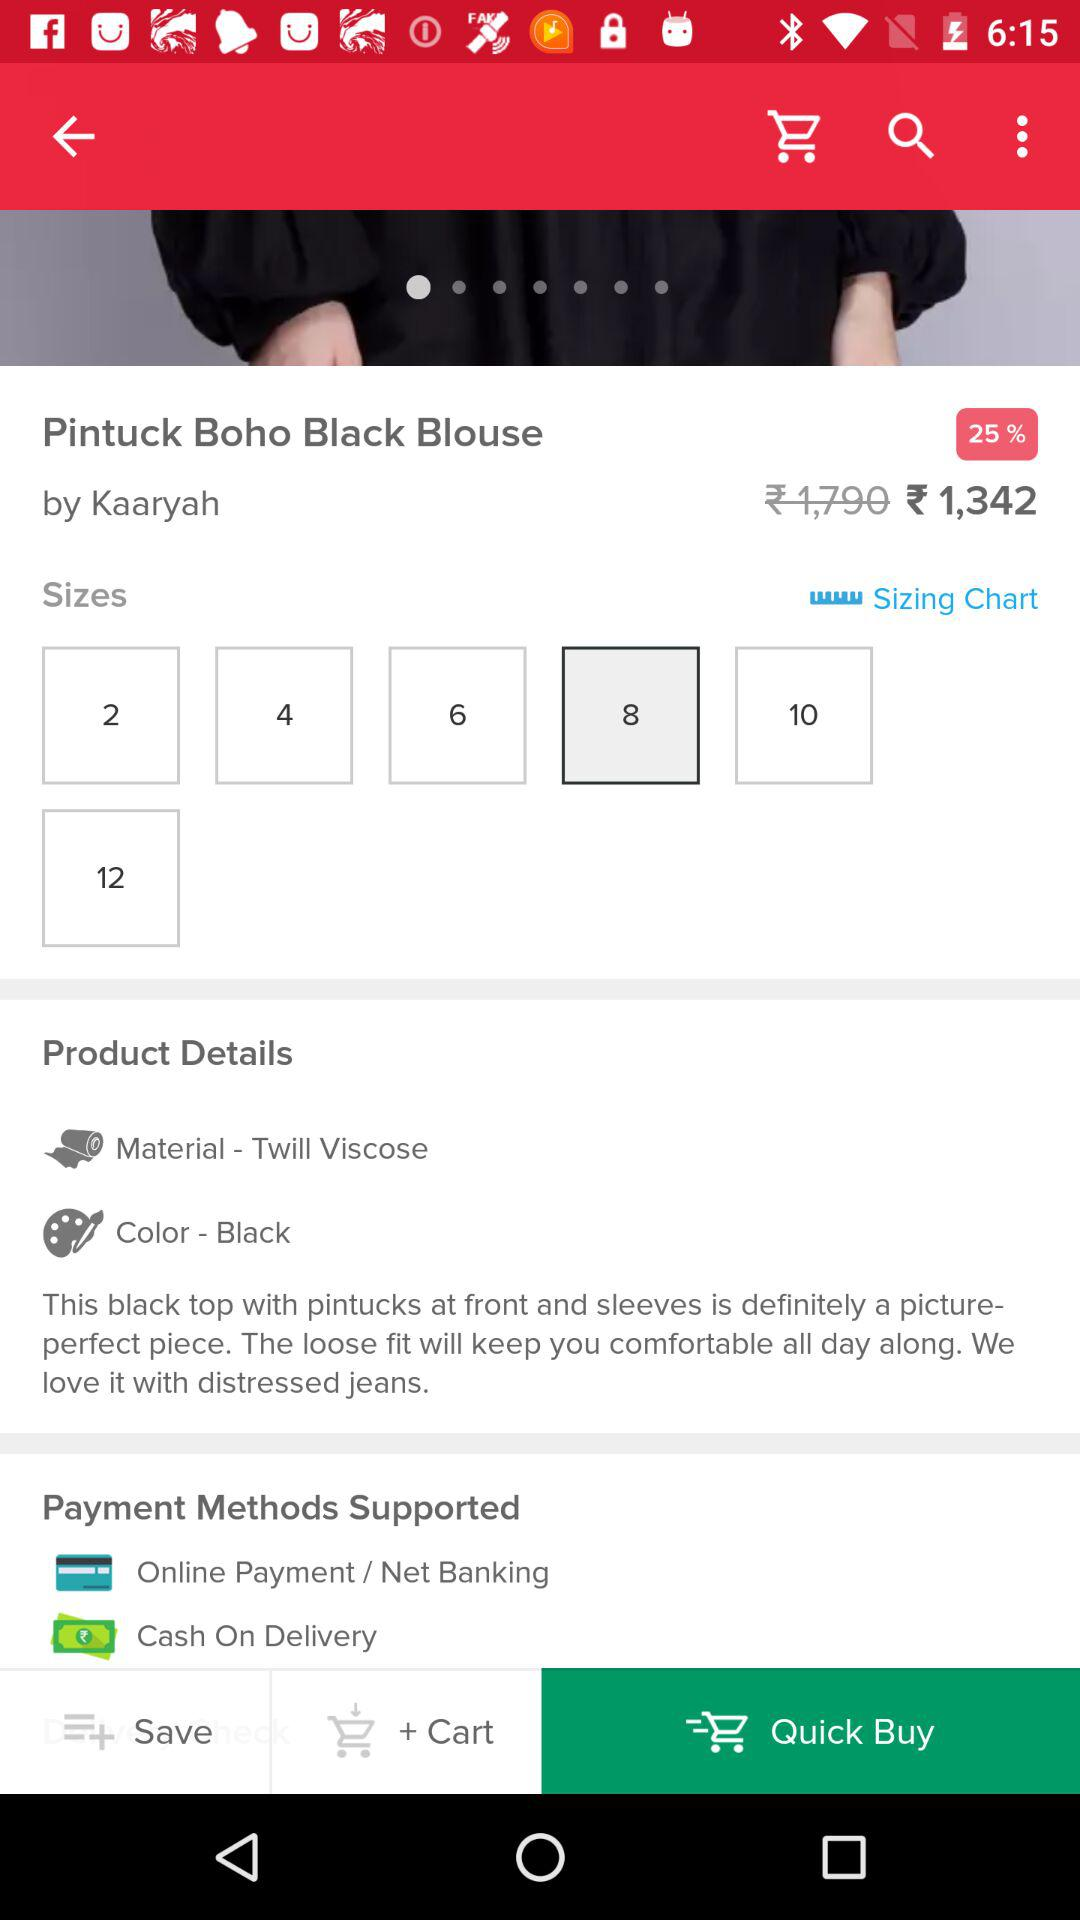What is the price of the Pintuck Boho Black Blouse? The price is ₹ 1,342. 